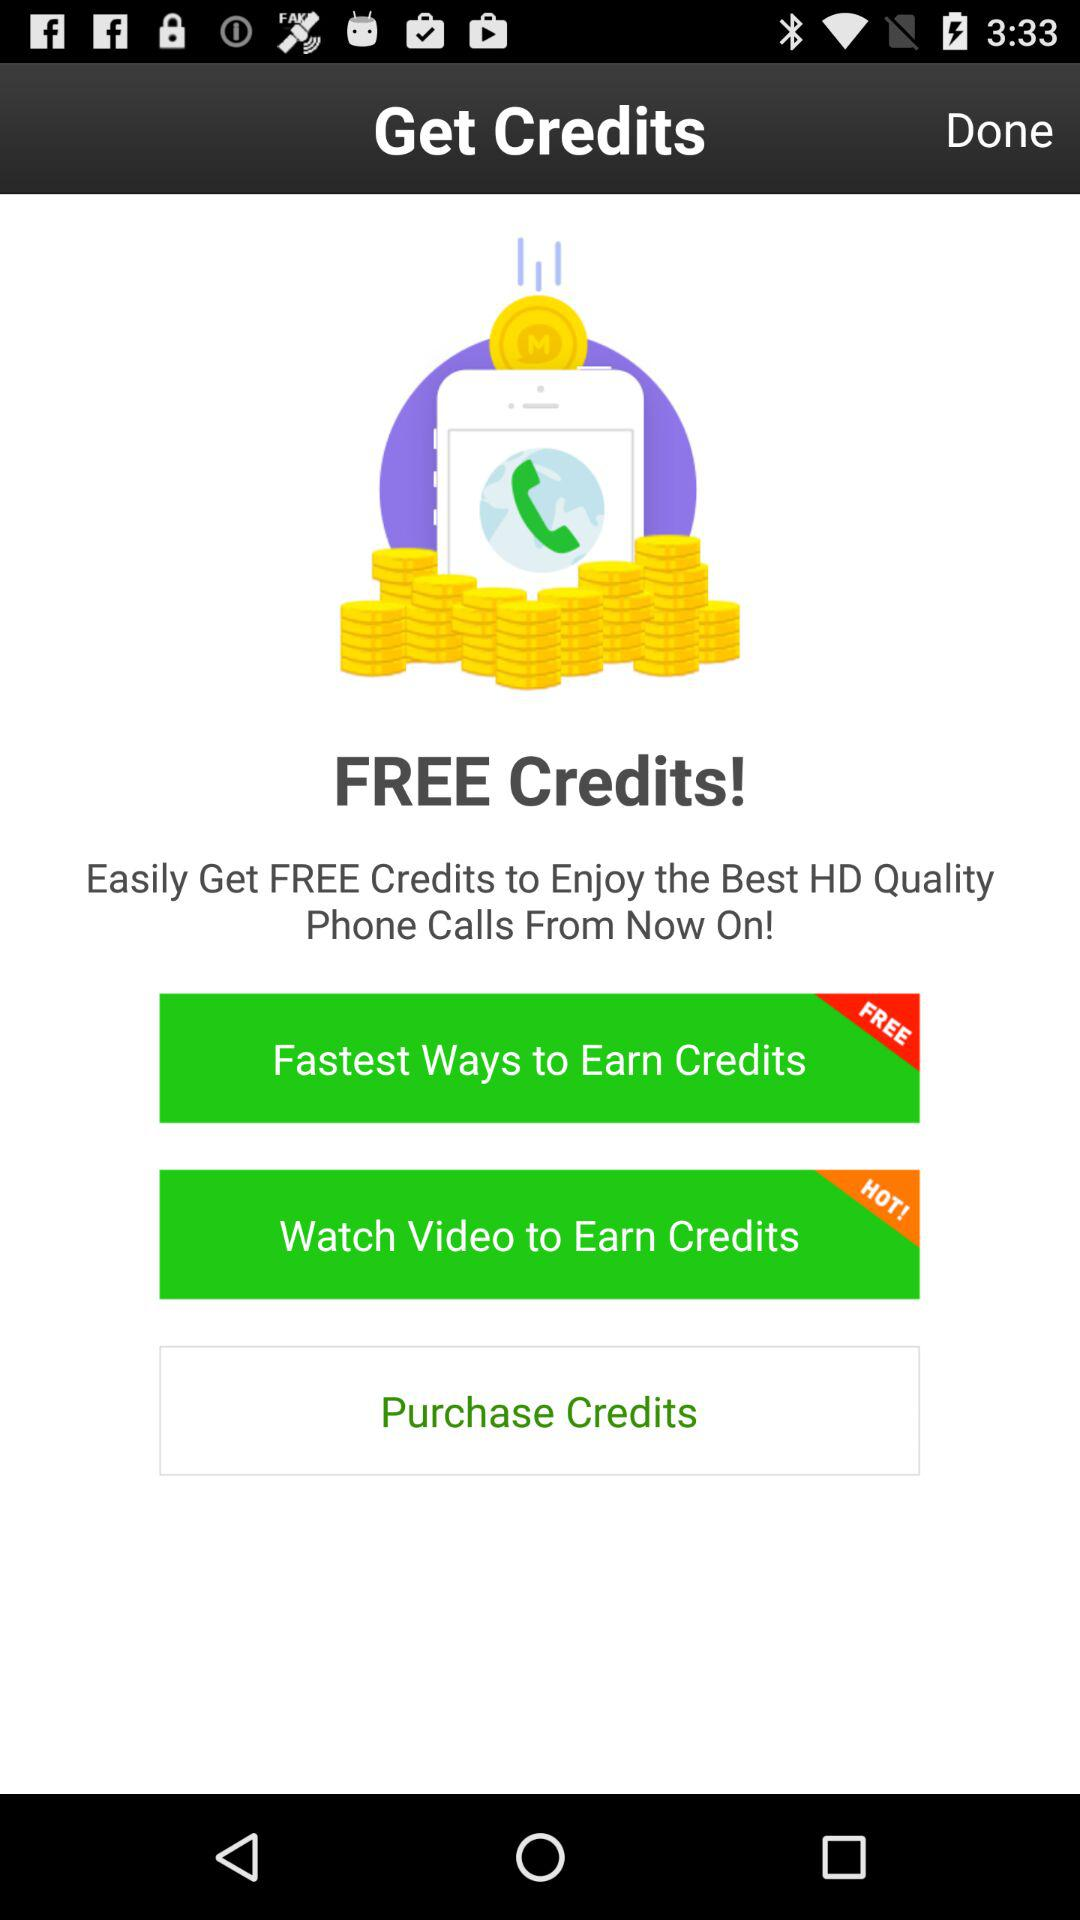What is the name of the application? The name of the application is "Get Credits". 